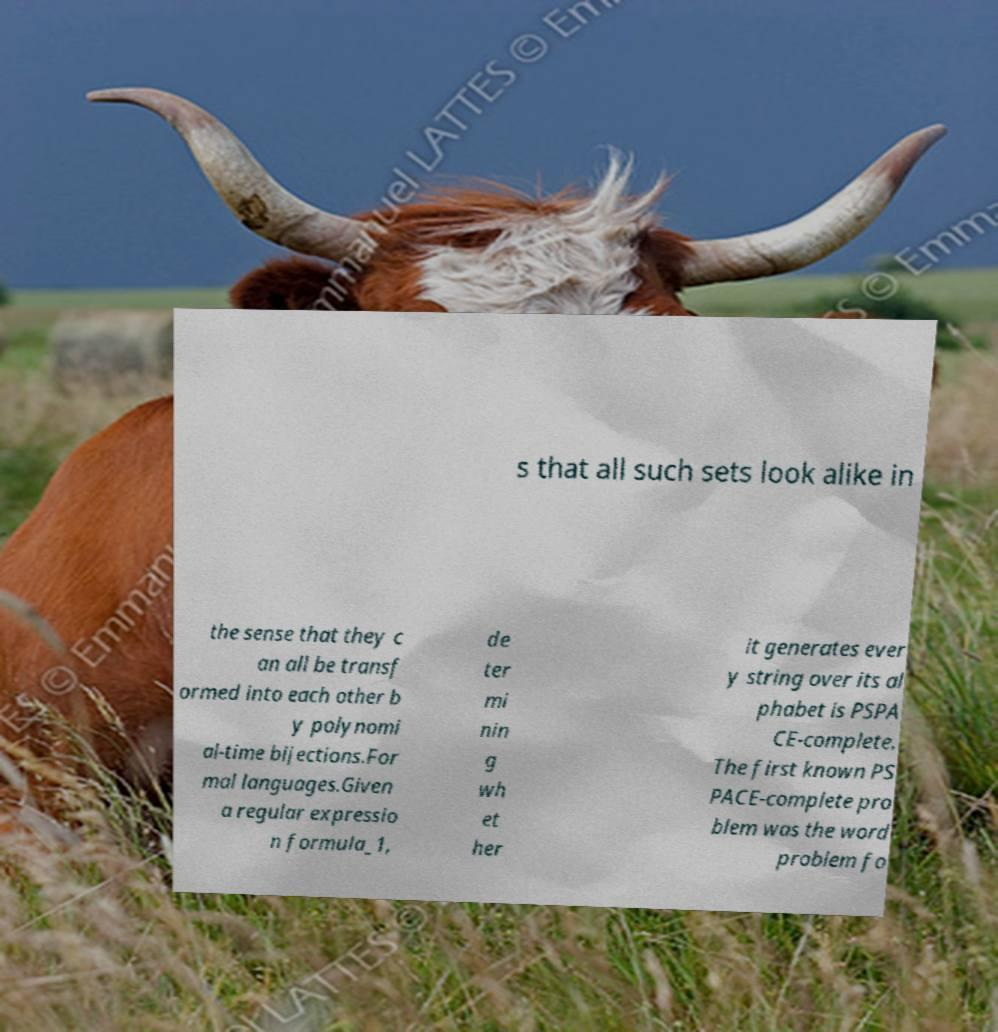Can you accurately transcribe the text from the provided image for me? s that all such sets look alike in the sense that they c an all be transf ormed into each other b y polynomi al-time bijections.For mal languages.Given a regular expressio n formula_1, de ter mi nin g wh et her it generates ever y string over its al phabet is PSPA CE-complete. The first known PS PACE-complete pro blem was the word problem fo 